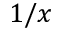<formula> <loc_0><loc_0><loc_500><loc_500>1 / x</formula> 